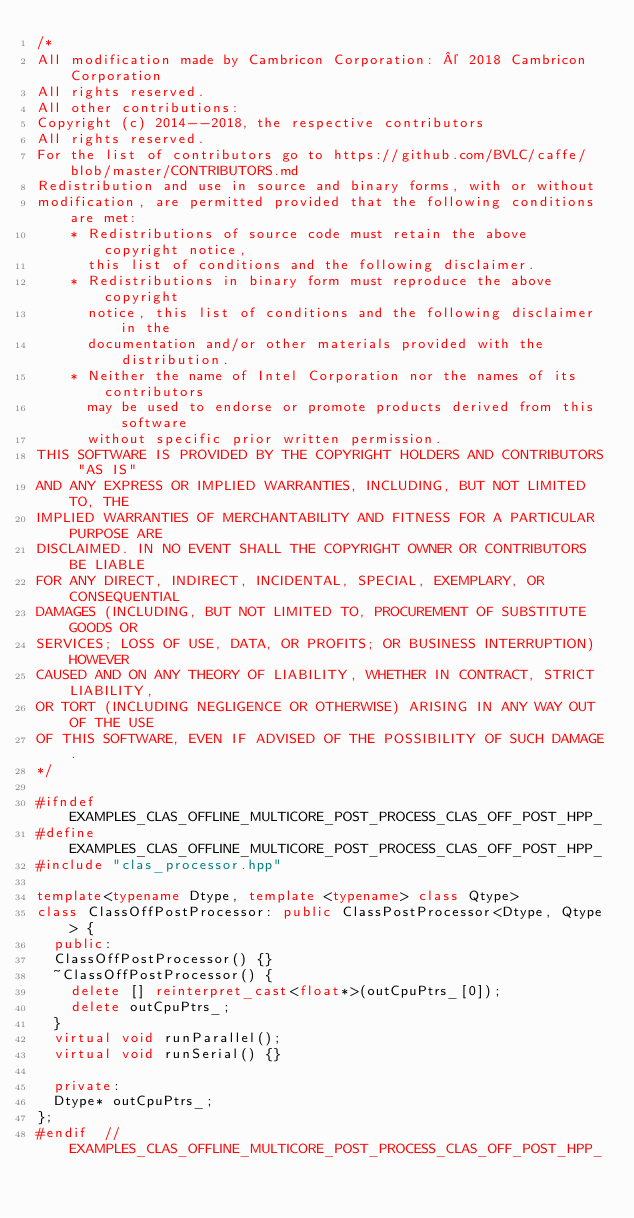Convert code to text. <code><loc_0><loc_0><loc_500><loc_500><_C++_>/*
All modification made by Cambricon Corporation: © 2018 Cambricon Corporation
All rights reserved.
All other contributions:
Copyright (c) 2014--2018, the respective contributors
All rights reserved.
For the list of contributors go to https://github.com/BVLC/caffe/blob/master/CONTRIBUTORS.md
Redistribution and use in source and binary forms, with or without
modification, are permitted provided that the following conditions are met:
    * Redistributions of source code must retain the above copyright notice,
      this list of conditions and the following disclaimer.
    * Redistributions in binary form must reproduce the above copyright
      notice, this list of conditions and the following disclaimer in the
      documentation and/or other materials provided with the distribution.
    * Neither the name of Intel Corporation nor the names of its contributors
      may be used to endorse or promote products derived from this software
      without specific prior written permission.
THIS SOFTWARE IS PROVIDED BY THE COPYRIGHT HOLDERS AND CONTRIBUTORS "AS IS"
AND ANY EXPRESS OR IMPLIED WARRANTIES, INCLUDING, BUT NOT LIMITED TO, THE
IMPLIED WARRANTIES OF MERCHANTABILITY AND FITNESS FOR A PARTICULAR PURPOSE ARE
DISCLAIMED. IN NO EVENT SHALL THE COPYRIGHT OWNER OR CONTRIBUTORS BE LIABLE
FOR ANY DIRECT, INDIRECT, INCIDENTAL, SPECIAL, EXEMPLARY, OR CONSEQUENTIAL
DAMAGES (INCLUDING, BUT NOT LIMITED TO, PROCUREMENT OF SUBSTITUTE GOODS OR
SERVICES; LOSS OF USE, DATA, OR PROFITS; OR BUSINESS INTERRUPTION) HOWEVER
CAUSED AND ON ANY THEORY OF LIABILITY, WHETHER IN CONTRACT, STRICT LIABILITY,
OR TORT (INCLUDING NEGLIGENCE OR OTHERWISE) ARISING IN ANY WAY OUT OF THE USE
OF THIS SOFTWARE, EVEN IF ADVISED OF THE POSSIBILITY OF SUCH DAMAGE.
*/

#ifndef EXAMPLES_CLAS_OFFLINE_MULTICORE_POST_PROCESS_CLAS_OFF_POST_HPP_
#define EXAMPLES_CLAS_OFFLINE_MULTICORE_POST_PROCESS_CLAS_OFF_POST_HPP_
#include "clas_processor.hpp"

template<typename Dtype, template <typename> class Qtype>
class ClassOffPostProcessor: public ClassPostProcessor<Dtype, Qtype> {
  public:
  ClassOffPostProcessor() {}
  ~ClassOffPostProcessor() {
    delete [] reinterpret_cast<float*>(outCpuPtrs_[0]);
    delete outCpuPtrs_;
  }
  virtual void runParallel();
  virtual void runSerial() {}

  private:
  Dtype* outCpuPtrs_;
};
#endif  // EXAMPLES_CLAS_OFFLINE_MULTICORE_POST_PROCESS_CLAS_OFF_POST_HPP_
</code> 